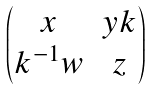Convert formula to latex. <formula><loc_0><loc_0><loc_500><loc_500>\begin{pmatrix} x & y k \\ k ^ { - 1 } w & z \end{pmatrix}</formula> 